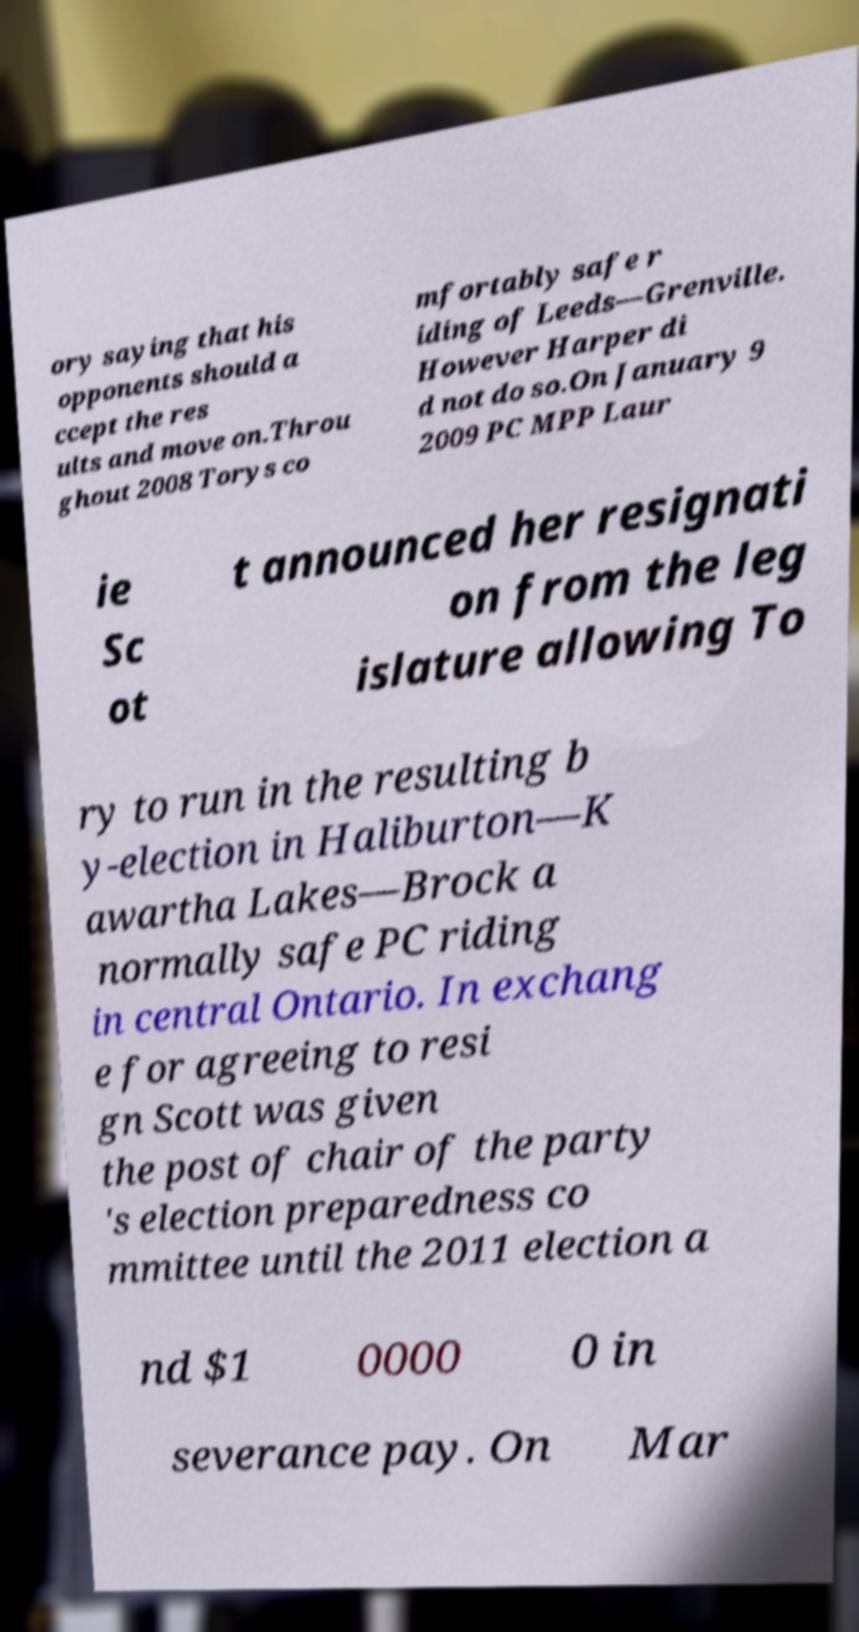Can you read and provide the text displayed in the image?This photo seems to have some interesting text. Can you extract and type it out for me? ory saying that his opponents should a ccept the res ults and move on.Throu ghout 2008 Torys co mfortably safe r iding of Leeds—Grenville. However Harper di d not do so.On January 9 2009 PC MPP Laur ie Sc ot t announced her resignati on from the leg islature allowing To ry to run in the resulting b y-election in Haliburton—K awartha Lakes—Brock a normally safe PC riding in central Ontario. In exchang e for agreeing to resi gn Scott was given the post of chair of the party 's election preparedness co mmittee until the 2011 election a nd $1 0000 0 in severance pay. On Mar 